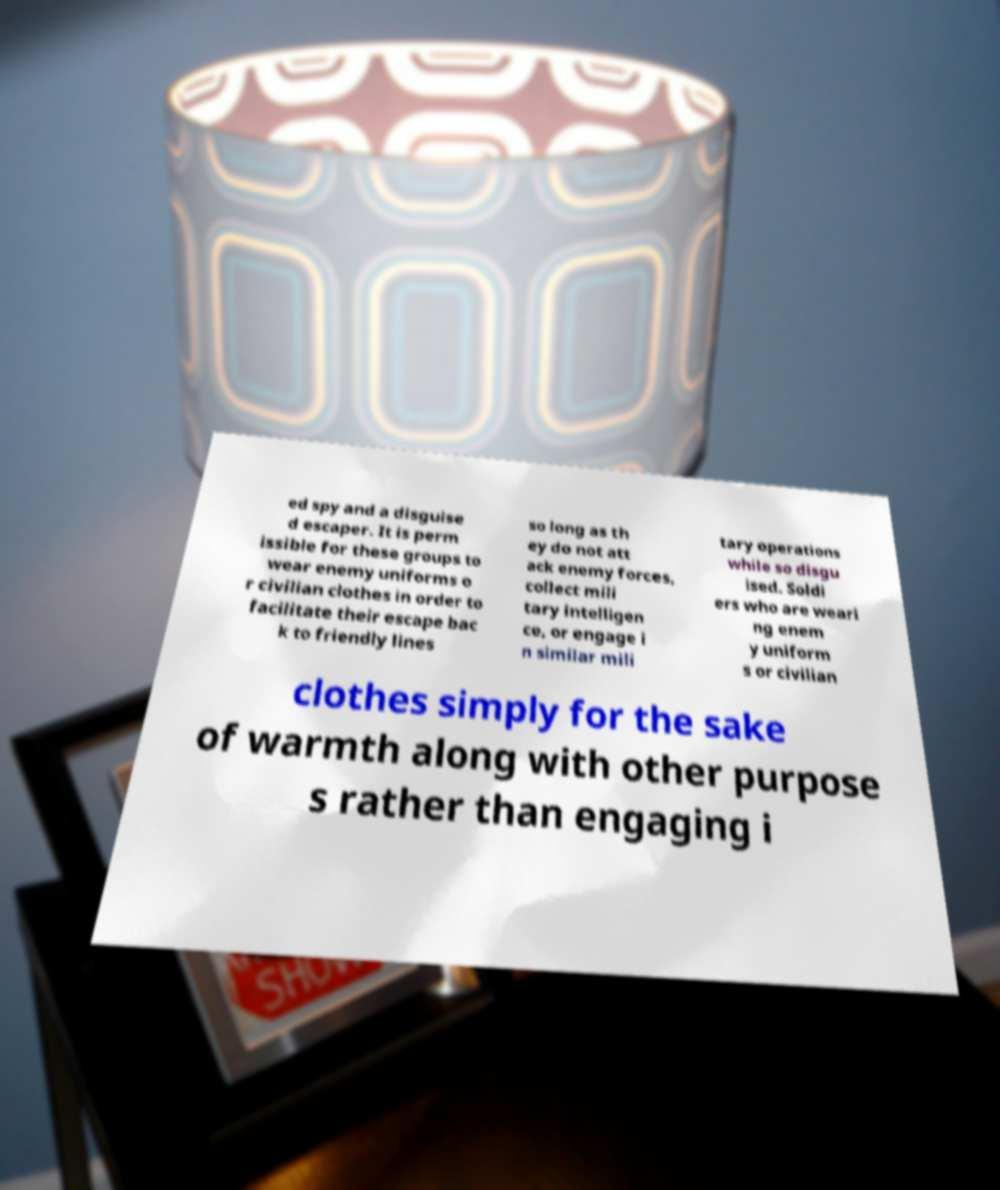I need the written content from this picture converted into text. Can you do that? ed spy and a disguise d escaper. It is perm issible for these groups to wear enemy uniforms o r civilian clothes in order to facilitate their escape bac k to friendly lines so long as th ey do not att ack enemy forces, collect mili tary intelligen ce, or engage i n similar mili tary operations while so disgu ised. Soldi ers who are weari ng enem y uniform s or civilian clothes simply for the sake of warmth along with other purpose s rather than engaging i 